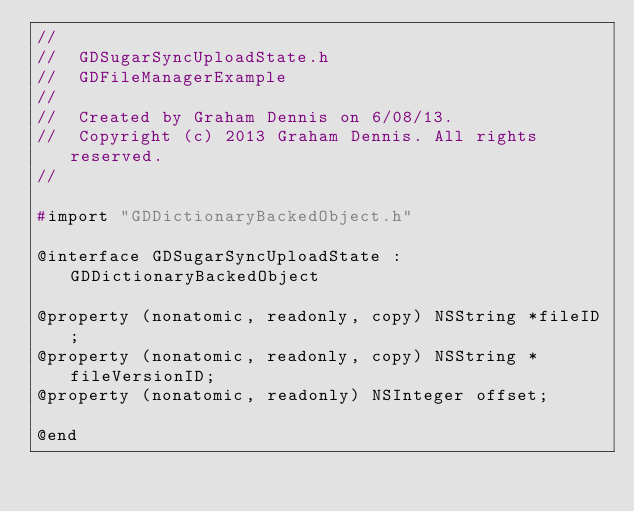<code> <loc_0><loc_0><loc_500><loc_500><_C_>//
//  GDSugarSyncUploadState.h
//  GDFileManagerExample
//
//  Created by Graham Dennis on 6/08/13.
//  Copyright (c) 2013 Graham Dennis. All rights reserved.
//

#import "GDDictionaryBackedObject.h"

@interface GDSugarSyncUploadState : GDDictionaryBackedObject

@property (nonatomic, readonly, copy) NSString *fileID;
@property (nonatomic, readonly, copy) NSString *fileVersionID;
@property (nonatomic, readonly) NSInteger offset;

@end
</code> 